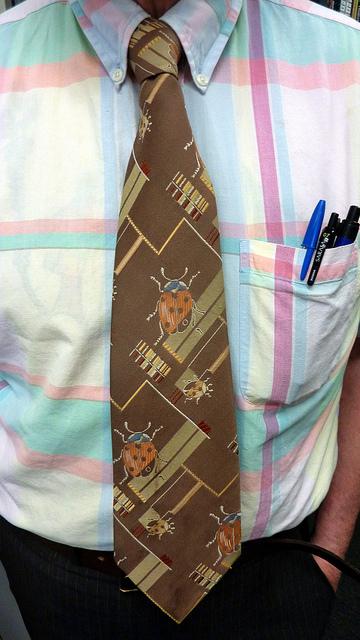Where are the pens?
Short answer required. Pocket. Are there pens in the shirt pocket?
Concise answer only. Yes. Does the shirt match the tie?
Concise answer only. No. 